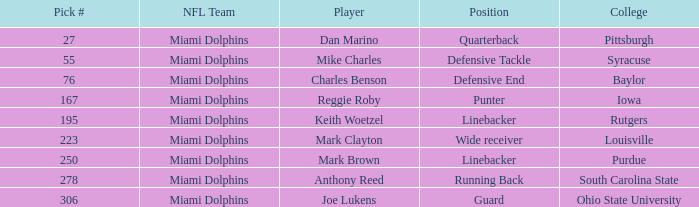If the Position is Running Back what is the Total number of Pick #? 1.0. 